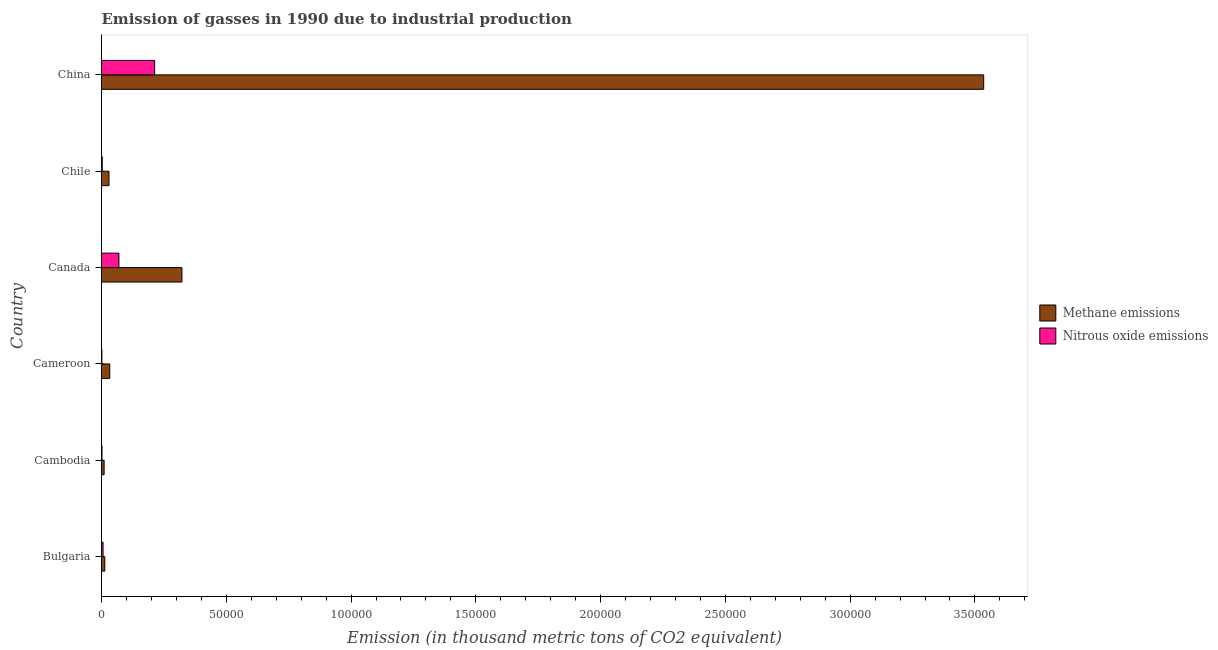How many different coloured bars are there?
Give a very brief answer. 2. How many groups of bars are there?
Keep it short and to the point. 6. Are the number of bars per tick equal to the number of legend labels?
Provide a short and direct response. Yes. How many bars are there on the 6th tick from the top?
Your response must be concise. 2. What is the label of the 4th group of bars from the top?
Ensure brevity in your answer.  Cameroon. What is the amount of nitrous oxide emissions in Cameroon?
Make the answer very short. 155. Across all countries, what is the maximum amount of methane emissions?
Provide a succinct answer. 3.54e+05. Across all countries, what is the minimum amount of methane emissions?
Give a very brief answer. 1049.6. In which country was the amount of methane emissions maximum?
Ensure brevity in your answer.  China. In which country was the amount of methane emissions minimum?
Keep it short and to the point. Cambodia. What is the total amount of methane emissions in the graph?
Provide a succinct answer. 3.94e+05. What is the difference between the amount of methane emissions in Bulgaria and that in Cameroon?
Make the answer very short. -1994.5. What is the difference between the amount of methane emissions in Cameroon and the amount of nitrous oxide emissions in China?
Provide a succinct answer. -1.80e+04. What is the average amount of methane emissions per country?
Your answer should be very brief. 6.57e+04. What is the difference between the amount of nitrous oxide emissions and amount of methane emissions in Cameroon?
Offer a terse response. -3158.1. What is the ratio of the amount of methane emissions in Bulgaria to that in China?
Your answer should be very brief. 0. Is the difference between the amount of methane emissions in Canada and China greater than the difference between the amount of nitrous oxide emissions in Canada and China?
Ensure brevity in your answer.  No. What is the difference between the highest and the second highest amount of nitrous oxide emissions?
Offer a very short reply. 1.43e+04. What is the difference between the highest and the lowest amount of nitrous oxide emissions?
Keep it short and to the point. 2.11e+04. What does the 1st bar from the top in Cameroon represents?
Provide a short and direct response. Nitrous oxide emissions. What does the 2nd bar from the bottom in Cameroon represents?
Make the answer very short. Nitrous oxide emissions. How many bars are there?
Keep it short and to the point. 12. How many countries are there in the graph?
Your response must be concise. 6. What is the difference between two consecutive major ticks on the X-axis?
Ensure brevity in your answer.  5.00e+04. Are the values on the major ticks of X-axis written in scientific E-notation?
Offer a very short reply. No. Does the graph contain any zero values?
Offer a terse response. No. Does the graph contain grids?
Provide a short and direct response. No. How are the legend labels stacked?
Give a very brief answer. Vertical. What is the title of the graph?
Provide a succinct answer. Emission of gasses in 1990 due to industrial production. What is the label or title of the X-axis?
Your answer should be very brief. Emission (in thousand metric tons of CO2 equivalent). What is the label or title of the Y-axis?
Ensure brevity in your answer.  Country. What is the Emission (in thousand metric tons of CO2 equivalent) of Methane emissions in Bulgaria?
Provide a succinct answer. 1318.6. What is the Emission (in thousand metric tons of CO2 equivalent) in Nitrous oxide emissions in Bulgaria?
Ensure brevity in your answer.  622. What is the Emission (in thousand metric tons of CO2 equivalent) in Methane emissions in Cambodia?
Offer a very short reply. 1049.6. What is the Emission (in thousand metric tons of CO2 equivalent) in Nitrous oxide emissions in Cambodia?
Give a very brief answer. 210.2. What is the Emission (in thousand metric tons of CO2 equivalent) of Methane emissions in Cameroon?
Your answer should be very brief. 3313.1. What is the Emission (in thousand metric tons of CO2 equivalent) in Nitrous oxide emissions in Cameroon?
Your response must be concise. 155. What is the Emission (in thousand metric tons of CO2 equivalent) of Methane emissions in Canada?
Your answer should be compact. 3.22e+04. What is the Emission (in thousand metric tons of CO2 equivalent) in Nitrous oxide emissions in Canada?
Provide a succinct answer. 6979.7. What is the Emission (in thousand metric tons of CO2 equivalent) of Methane emissions in Chile?
Provide a succinct answer. 3002.7. What is the Emission (in thousand metric tons of CO2 equivalent) of Nitrous oxide emissions in Chile?
Your answer should be very brief. 290.1. What is the Emission (in thousand metric tons of CO2 equivalent) of Methane emissions in China?
Provide a succinct answer. 3.54e+05. What is the Emission (in thousand metric tons of CO2 equivalent) of Nitrous oxide emissions in China?
Give a very brief answer. 2.13e+04. Across all countries, what is the maximum Emission (in thousand metric tons of CO2 equivalent) in Methane emissions?
Your answer should be compact. 3.54e+05. Across all countries, what is the maximum Emission (in thousand metric tons of CO2 equivalent) in Nitrous oxide emissions?
Keep it short and to the point. 2.13e+04. Across all countries, what is the minimum Emission (in thousand metric tons of CO2 equivalent) of Methane emissions?
Ensure brevity in your answer.  1049.6. Across all countries, what is the minimum Emission (in thousand metric tons of CO2 equivalent) in Nitrous oxide emissions?
Your answer should be very brief. 155. What is the total Emission (in thousand metric tons of CO2 equivalent) in Methane emissions in the graph?
Provide a succinct answer. 3.94e+05. What is the total Emission (in thousand metric tons of CO2 equivalent) in Nitrous oxide emissions in the graph?
Your answer should be very brief. 2.96e+04. What is the difference between the Emission (in thousand metric tons of CO2 equivalent) in Methane emissions in Bulgaria and that in Cambodia?
Your answer should be very brief. 269. What is the difference between the Emission (in thousand metric tons of CO2 equivalent) in Nitrous oxide emissions in Bulgaria and that in Cambodia?
Provide a succinct answer. 411.8. What is the difference between the Emission (in thousand metric tons of CO2 equivalent) in Methane emissions in Bulgaria and that in Cameroon?
Ensure brevity in your answer.  -1994.5. What is the difference between the Emission (in thousand metric tons of CO2 equivalent) in Nitrous oxide emissions in Bulgaria and that in Cameroon?
Your answer should be very brief. 467. What is the difference between the Emission (in thousand metric tons of CO2 equivalent) of Methane emissions in Bulgaria and that in Canada?
Provide a succinct answer. -3.09e+04. What is the difference between the Emission (in thousand metric tons of CO2 equivalent) of Nitrous oxide emissions in Bulgaria and that in Canada?
Make the answer very short. -6357.7. What is the difference between the Emission (in thousand metric tons of CO2 equivalent) in Methane emissions in Bulgaria and that in Chile?
Provide a succinct answer. -1684.1. What is the difference between the Emission (in thousand metric tons of CO2 equivalent) of Nitrous oxide emissions in Bulgaria and that in Chile?
Provide a short and direct response. 331.9. What is the difference between the Emission (in thousand metric tons of CO2 equivalent) of Methane emissions in Bulgaria and that in China?
Provide a short and direct response. -3.52e+05. What is the difference between the Emission (in thousand metric tons of CO2 equivalent) in Nitrous oxide emissions in Bulgaria and that in China?
Your answer should be very brief. -2.07e+04. What is the difference between the Emission (in thousand metric tons of CO2 equivalent) of Methane emissions in Cambodia and that in Cameroon?
Ensure brevity in your answer.  -2263.5. What is the difference between the Emission (in thousand metric tons of CO2 equivalent) in Nitrous oxide emissions in Cambodia and that in Cameroon?
Offer a very short reply. 55.2. What is the difference between the Emission (in thousand metric tons of CO2 equivalent) of Methane emissions in Cambodia and that in Canada?
Provide a short and direct response. -3.12e+04. What is the difference between the Emission (in thousand metric tons of CO2 equivalent) of Nitrous oxide emissions in Cambodia and that in Canada?
Offer a terse response. -6769.5. What is the difference between the Emission (in thousand metric tons of CO2 equivalent) in Methane emissions in Cambodia and that in Chile?
Make the answer very short. -1953.1. What is the difference between the Emission (in thousand metric tons of CO2 equivalent) in Nitrous oxide emissions in Cambodia and that in Chile?
Make the answer very short. -79.9. What is the difference between the Emission (in thousand metric tons of CO2 equivalent) of Methane emissions in Cambodia and that in China?
Your answer should be very brief. -3.52e+05. What is the difference between the Emission (in thousand metric tons of CO2 equivalent) of Nitrous oxide emissions in Cambodia and that in China?
Your answer should be very brief. -2.11e+04. What is the difference between the Emission (in thousand metric tons of CO2 equivalent) in Methane emissions in Cameroon and that in Canada?
Make the answer very short. -2.89e+04. What is the difference between the Emission (in thousand metric tons of CO2 equivalent) in Nitrous oxide emissions in Cameroon and that in Canada?
Give a very brief answer. -6824.7. What is the difference between the Emission (in thousand metric tons of CO2 equivalent) of Methane emissions in Cameroon and that in Chile?
Your answer should be very brief. 310.4. What is the difference between the Emission (in thousand metric tons of CO2 equivalent) in Nitrous oxide emissions in Cameroon and that in Chile?
Provide a succinct answer. -135.1. What is the difference between the Emission (in thousand metric tons of CO2 equivalent) in Methane emissions in Cameroon and that in China?
Keep it short and to the point. -3.50e+05. What is the difference between the Emission (in thousand metric tons of CO2 equivalent) of Nitrous oxide emissions in Cameroon and that in China?
Your response must be concise. -2.11e+04. What is the difference between the Emission (in thousand metric tons of CO2 equivalent) of Methane emissions in Canada and that in Chile?
Provide a short and direct response. 2.92e+04. What is the difference between the Emission (in thousand metric tons of CO2 equivalent) in Nitrous oxide emissions in Canada and that in Chile?
Give a very brief answer. 6689.6. What is the difference between the Emission (in thousand metric tons of CO2 equivalent) of Methane emissions in Canada and that in China?
Offer a terse response. -3.21e+05. What is the difference between the Emission (in thousand metric tons of CO2 equivalent) of Nitrous oxide emissions in Canada and that in China?
Your answer should be compact. -1.43e+04. What is the difference between the Emission (in thousand metric tons of CO2 equivalent) in Methane emissions in Chile and that in China?
Ensure brevity in your answer.  -3.51e+05. What is the difference between the Emission (in thousand metric tons of CO2 equivalent) in Nitrous oxide emissions in Chile and that in China?
Your response must be concise. -2.10e+04. What is the difference between the Emission (in thousand metric tons of CO2 equivalent) of Methane emissions in Bulgaria and the Emission (in thousand metric tons of CO2 equivalent) of Nitrous oxide emissions in Cambodia?
Keep it short and to the point. 1108.4. What is the difference between the Emission (in thousand metric tons of CO2 equivalent) of Methane emissions in Bulgaria and the Emission (in thousand metric tons of CO2 equivalent) of Nitrous oxide emissions in Cameroon?
Give a very brief answer. 1163.6. What is the difference between the Emission (in thousand metric tons of CO2 equivalent) in Methane emissions in Bulgaria and the Emission (in thousand metric tons of CO2 equivalent) in Nitrous oxide emissions in Canada?
Your answer should be compact. -5661.1. What is the difference between the Emission (in thousand metric tons of CO2 equivalent) in Methane emissions in Bulgaria and the Emission (in thousand metric tons of CO2 equivalent) in Nitrous oxide emissions in Chile?
Give a very brief answer. 1028.5. What is the difference between the Emission (in thousand metric tons of CO2 equivalent) in Methane emissions in Bulgaria and the Emission (in thousand metric tons of CO2 equivalent) in Nitrous oxide emissions in China?
Provide a succinct answer. -2.00e+04. What is the difference between the Emission (in thousand metric tons of CO2 equivalent) of Methane emissions in Cambodia and the Emission (in thousand metric tons of CO2 equivalent) of Nitrous oxide emissions in Cameroon?
Provide a succinct answer. 894.6. What is the difference between the Emission (in thousand metric tons of CO2 equivalent) of Methane emissions in Cambodia and the Emission (in thousand metric tons of CO2 equivalent) of Nitrous oxide emissions in Canada?
Provide a short and direct response. -5930.1. What is the difference between the Emission (in thousand metric tons of CO2 equivalent) in Methane emissions in Cambodia and the Emission (in thousand metric tons of CO2 equivalent) in Nitrous oxide emissions in Chile?
Make the answer very short. 759.5. What is the difference between the Emission (in thousand metric tons of CO2 equivalent) in Methane emissions in Cambodia and the Emission (in thousand metric tons of CO2 equivalent) in Nitrous oxide emissions in China?
Offer a terse response. -2.02e+04. What is the difference between the Emission (in thousand metric tons of CO2 equivalent) in Methane emissions in Cameroon and the Emission (in thousand metric tons of CO2 equivalent) in Nitrous oxide emissions in Canada?
Your answer should be compact. -3666.6. What is the difference between the Emission (in thousand metric tons of CO2 equivalent) in Methane emissions in Cameroon and the Emission (in thousand metric tons of CO2 equivalent) in Nitrous oxide emissions in Chile?
Provide a short and direct response. 3023. What is the difference between the Emission (in thousand metric tons of CO2 equivalent) of Methane emissions in Cameroon and the Emission (in thousand metric tons of CO2 equivalent) of Nitrous oxide emissions in China?
Your answer should be compact. -1.80e+04. What is the difference between the Emission (in thousand metric tons of CO2 equivalent) of Methane emissions in Canada and the Emission (in thousand metric tons of CO2 equivalent) of Nitrous oxide emissions in Chile?
Your answer should be very brief. 3.19e+04. What is the difference between the Emission (in thousand metric tons of CO2 equivalent) of Methane emissions in Canada and the Emission (in thousand metric tons of CO2 equivalent) of Nitrous oxide emissions in China?
Provide a succinct answer. 1.09e+04. What is the difference between the Emission (in thousand metric tons of CO2 equivalent) in Methane emissions in Chile and the Emission (in thousand metric tons of CO2 equivalent) in Nitrous oxide emissions in China?
Offer a terse response. -1.83e+04. What is the average Emission (in thousand metric tons of CO2 equivalent) of Methane emissions per country?
Ensure brevity in your answer.  6.57e+04. What is the average Emission (in thousand metric tons of CO2 equivalent) of Nitrous oxide emissions per country?
Give a very brief answer. 4925.95. What is the difference between the Emission (in thousand metric tons of CO2 equivalent) in Methane emissions and Emission (in thousand metric tons of CO2 equivalent) in Nitrous oxide emissions in Bulgaria?
Ensure brevity in your answer.  696.6. What is the difference between the Emission (in thousand metric tons of CO2 equivalent) in Methane emissions and Emission (in thousand metric tons of CO2 equivalent) in Nitrous oxide emissions in Cambodia?
Keep it short and to the point. 839.4. What is the difference between the Emission (in thousand metric tons of CO2 equivalent) of Methane emissions and Emission (in thousand metric tons of CO2 equivalent) of Nitrous oxide emissions in Cameroon?
Make the answer very short. 3158.1. What is the difference between the Emission (in thousand metric tons of CO2 equivalent) of Methane emissions and Emission (in thousand metric tons of CO2 equivalent) of Nitrous oxide emissions in Canada?
Offer a terse response. 2.53e+04. What is the difference between the Emission (in thousand metric tons of CO2 equivalent) of Methane emissions and Emission (in thousand metric tons of CO2 equivalent) of Nitrous oxide emissions in Chile?
Give a very brief answer. 2712.6. What is the difference between the Emission (in thousand metric tons of CO2 equivalent) of Methane emissions and Emission (in thousand metric tons of CO2 equivalent) of Nitrous oxide emissions in China?
Provide a short and direct response. 3.32e+05. What is the ratio of the Emission (in thousand metric tons of CO2 equivalent) in Methane emissions in Bulgaria to that in Cambodia?
Keep it short and to the point. 1.26. What is the ratio of the Emission (in thousand metric tons of CO2 equivalent) of Nitrous oxide emissions in Bulgaria to that in Cambodia?
Your answer should be compact. 2.96. What is the ratio of the Emission (in thousand metric tons of CO2 equivalent) of Methane emissions in Bulgaria to that in Cameroon?
Offer a very short reply. 0.4. What is the ratio of the Emission (in thousand metric tons of CO2 equivalent) of Nitrous oxide emissions in Bulgaria to that in Cameroon?
Your answer should be very brief. 4.01. What is the ratio of the Emission (in thousand metric tons of CO2 equivalent) of Methane emissions in Bulgaria to that in Canada?
Your response must be concise. 0.04. What is the ratio of the Emission (in thousand metric tons of CO2 equivalent) of Nitrous oxide emissions in Bulgaria to that in Canada?
Give a very brief answer. 0.09. What is the ratio of the Emission (in thousand metric tons of CO2 equivalent) of Methane emissions in Bulgaria to that in Chile?
Offer a very short reply. 0.44. What is the ratio of the Emission (in thousand metric tons of CO2 equivalent) in Nitrous oxide emissions in Bulgaria to that in Chile?
Your answer should be very brief. 2.14. What is the ratio of the Emission (in thousand metric tons of CO2 equivalent) of Methane emissions in Bulgaria to that in China?
Your response must be concise. 0. What is the ratio of the Emission (in thousand metric tons of CO2 equivalent) of Nitrous oxide emissions in Bulgaria to that in China?
Keep it short and to the point. 0.03. What is the ratio of the Emission (in thousand metric tons of CO2 equivalent) in Methane emissions in Cambodia to that in Cameroon?
Provide a succinct answer. 0.32. What is the ratio of the Emission (in thousand metric tons of CO2 equivalent) in Nitrous oxide emissions in Cambodia to that in Cameroon?
Ensure brevity in your answer.  1.36. What is the ratio of the Emission (in thousand metric tons of CO2 equivalent) of Methane emissions in Cambodia to that in Canada?
Provide a short and direct response. 0.03. What is the ratio of the Emission (in thousand metric tons of CO2 equivalent) in Nitrous oxide emissions in Cambodia to that in Canada?
Give a very brief answer. 0.03. What is the ratio of the Emission (in thousand metric tons of CO2 equivalent) in Methane emissions in Cambodia to that in Chile?
Offer a very short reply. 0.35. What is the ratio of the Emission (in thousand metric tons of CO2 equivalent) of Nitrous oxide emissions in Cambodia to that in Chile?
Provide a short and direct response. 0.72. What is the ratio of the Emission (in thousand metric tons of CO2 equivalent) of Methane emissions in Cambodia to that in China?
Provide a short and direct response. 0. What is the ratio of the Emission (in thousand metric tons of CO2 equivalent) in Nitrous oxide emissions in Cambodia to that in China?
Provide a succinct answer. 0.01. What is the ratio of the Emission (in thousand metric tons of CO2 equivalent) of Methane emissions in Cameroon to that in Canada?
Offer a very short reply. 0.1. What is the ratio of the Emission (in thousand metric tons of CO2 equivalent) of Nitrous oxide emissions in Cameroon to that in Canada?
Ensure brevity in your answer.  0.02. What is the ratio of the Emission (in thousand metric tons of CO2 equivalent) of Methane emissions in Cameroon to that in Chile?
Provide a succinct answer. 1.1. What is the ratio of the Emission (in thousand metric tons of CO2 equivalent) of Nitrous oxide emissions in Cameroon to that in Chile?
Make the answer very short. 0.53. What is the ratio of the Emission (in thousand metric tons of CO2 equivalent) in Methane emissions in Cameroon to that in China?
Your answer should be very brief. 0.01. What is the ratio of the Emission (in thousand metric tons of CO2 equivalent) of Nitrous oxide emissions in Cameroon to that in China?
Ensure brevity in your answer.  0.01. What is the ratio of the Emission (in thousand metric tons of CO2 equivalent) in Methane emissions in Canada to that in Chile?
Offer a very short reply. 10.74. What is the ratio of the Emission (in thousand metric tons of CO2 equivalent) of Nitrous oxide emissions in Canada to that in Chile?
Offer a very short reply. 24.06. What is the ratio of the Emission (in thousand metric tons of CO2 equivalent) in Methane emissions in Canada to that in China?
Your answer should be very brief. 0.09. What is the ratio of the Emission (in thousand metric tons of CO2 equivalent) of Nitrous oxide emissions in Canada to that in China?
Your response must be concise. 0.33. What is the ratio of the Emission (in thousand metric tons of CO2 equivalent) in Methane emissions in Chile to that in China?
Your answer should be very brief. 0.01. What is the ratio of the Emission (in thousand metric tons of CO2 equivalent) of Nitrous oxide emissions in Chile to that in China?
Give a very brief answer. 0.01. What is the difference between the highest and the second highest Emission (in thousand metric tons of CO2 equivalent) of Methane emissions?
Keep it short and to the point. 3.21e+05. What is the difference between the highest and the second highest Emission (in thousand metric tons of CO2 equivalent) in Nitrous oxide emissions?
Ensure brevity in your answer.  1.43e+04. What is the difference between the highest and the lowest Emission (in thousand metric tons of CO2 equivalent) in Methane emissions?
Provide a succinct answer. 3.52e+05. What is the difference between the highest and the lowest Emission (in thousand metric tons of CO2 equivalent) of Nitrous oxide emissions?
Ensure brevity in your answer.  2.11e+04. 